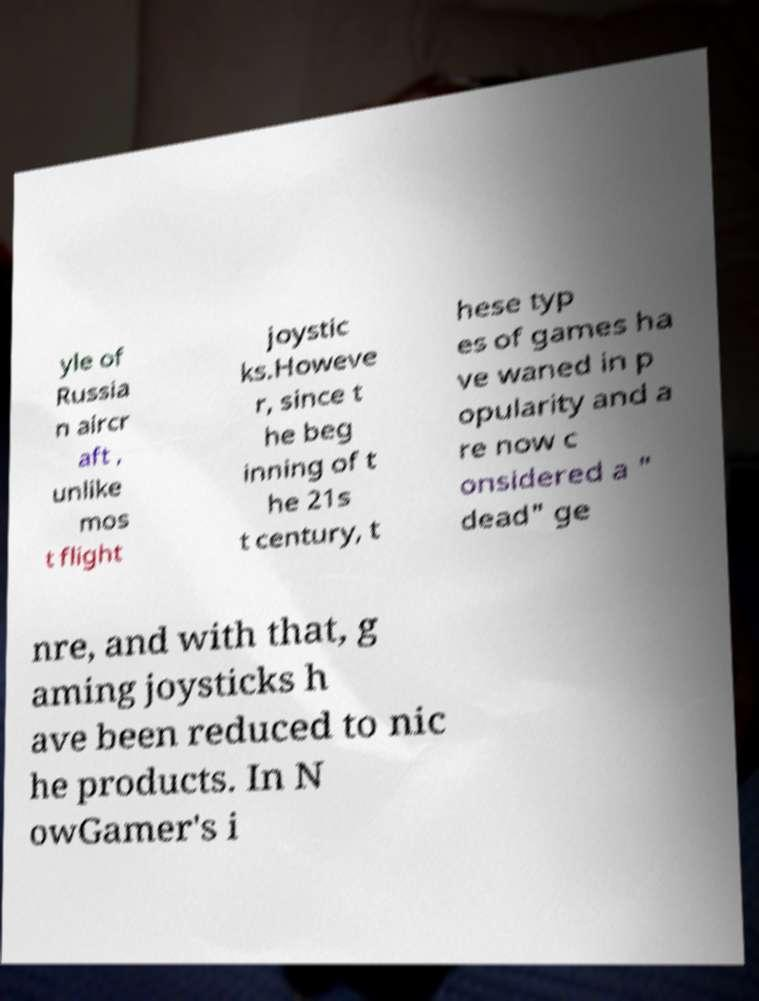What messages or text are displayed in this image? I need them in a readable, typed format. yle of Russia n aircr aft , unlike mos t flight joystic ks.Howeve r, since t he beg inning of t he 21s t century, t hese typ es of games ha ve waned in p opularity and a re now c onsidered a " dead" ge nre, and with that, g aming joysticks h ave been reduced to nic he products. In N owGamer's i 